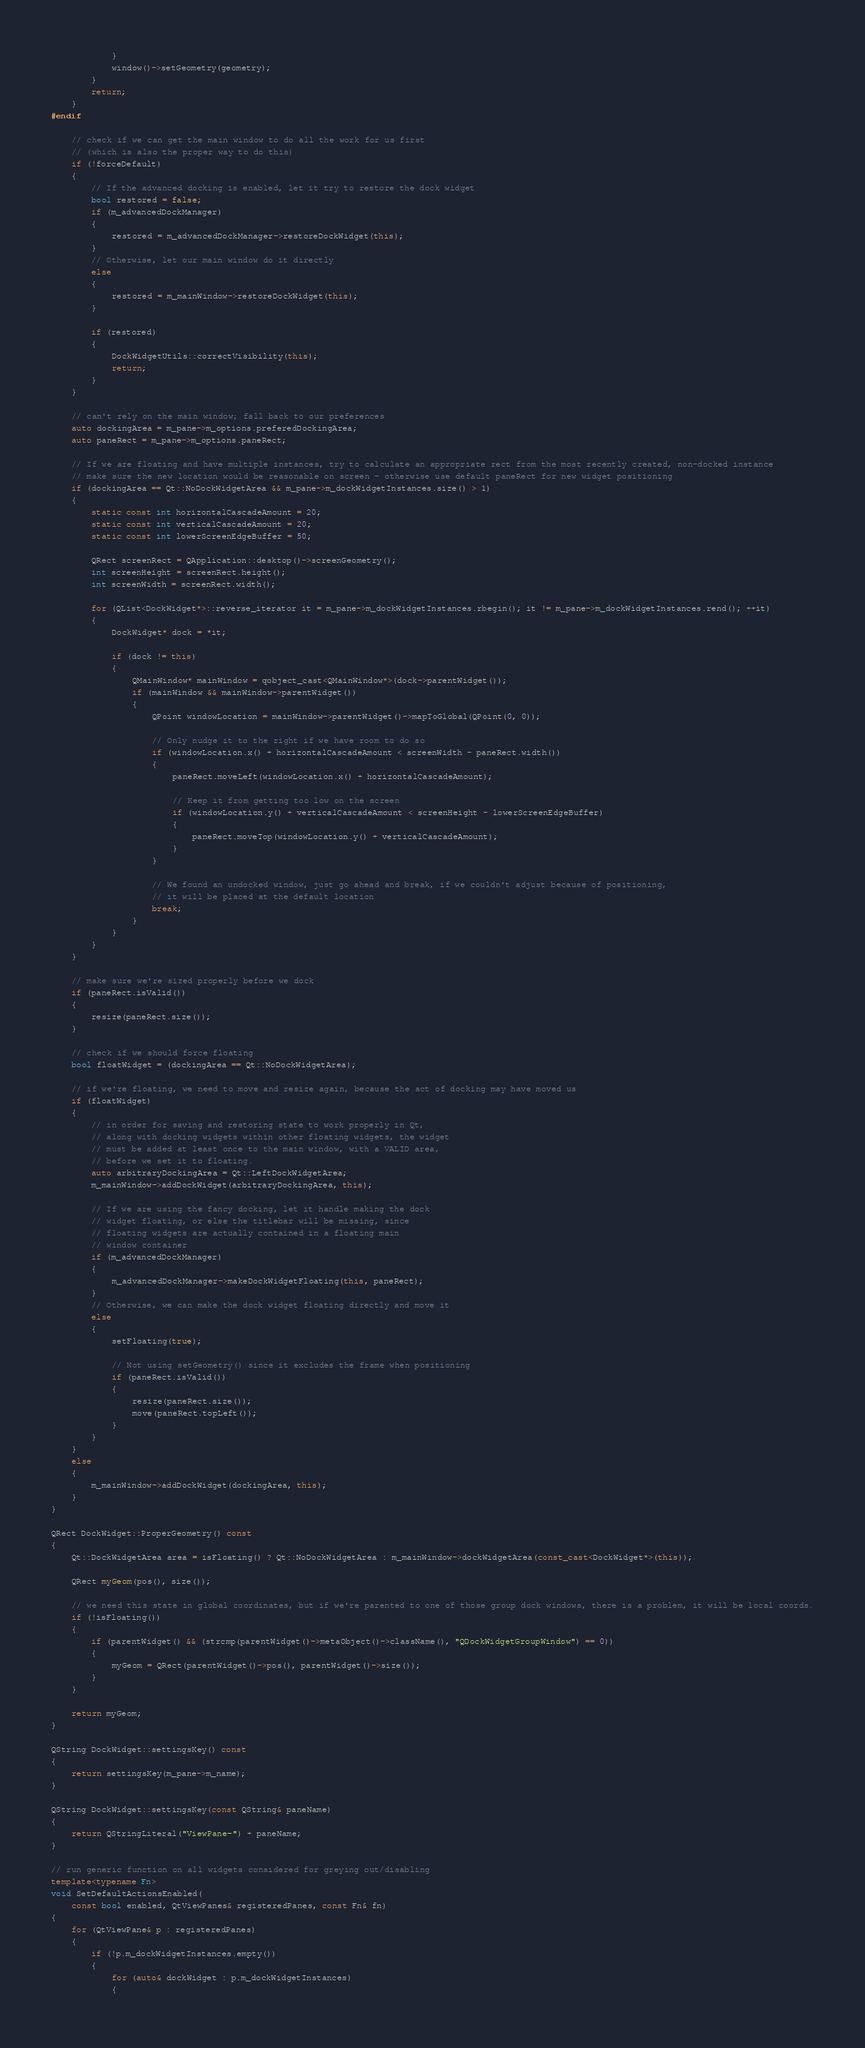Convert code to text. <code><loc_0><loc_0><loc_500><loc_500><_C++_>            }
            window()->setGeometry(geometry);
        }
        return;
    }
#endif

    // check if we can get the main window to do all the work for us first
    // (which is also the proper way to do this)
    if (!forceDefault)
    {
        // If the advanced docking is enabled, let it try to restore the dock widget
        bool restored = false;
        if (m_advancedDockManager)
        {
            restored = m_advancedDockManager->restoreDockWidget(this);
        }
        // Otherwise, let our main window do it directly
        else
        {
            restored = m_mainWindow->restoreDockWidget(this);
        }

        if (restored)
        {
            DockWidgetUtils::correctVisibility(this);
            return;
        }
    }

    // can't rely on the main window; fall back to our preferences
    auto dockingArea = m_pane->m_options.preferedDockingArea;
    auto paneRect = m_pane->m_options.paneRect;

    // If we are floating and have multiple instances, try to calculate an appropriate rect from the most recently created, non-docked instance
    // make sure the new location would be reasonable on screen - otherwise use default paneRect for new widget positioning
    if (dockingArea == Qt::NoDockWidgetArea && m_pane->m_dockWidgetInstances.size() > 1)
    {
        static const int horizontalCascadeAmount = 20;
        static const int verticalCascadeAmount = 20;
        static const int lowerScreenEdgeBuffer = 50;

        QRect screenRect = QApplication::desktop()->screenGeometry();
        int screenHeight = screenRect.height();
        int screenWidth = screenRect.width();

        for (QList<DockWidget*>::reverse_iterator it = m_pane->m_dockWidgetInstances.rbegin(); it != m_pane->m_dockWidgetInstances.rend(); ++it)
        {
            DockWidget* dock = *it;

            if (dock != this)
            {
                QMainWindow* mainWindow = qobject_cast<QMainWindow*>(dock->parentWidget());
                if (mainWindow && mainWindow->parentWidget())
                {
                    QPoint windowLocation = mainWindow->parentWidget()->mapToGlobal(QPoint(0, 0));

                    // Only nudge it to the right if we have room to do so
                    if (windowLocation.x() + horizontalCascadeAmount < screenWidth - paneRect.width())
                    {
                        paneRect.moveLeft(windowLocation.x() + horizontalCascadeAmount);

                        // Keep it from getting too low on the screen
                        if (windowLocation.y() + verticalCascadeAmount < screenHeight - lowerScreenEdgeBuffer)
                        {
                            paneRect.moveTop(windowLocation.y() + verticalCascadeAmount);
                        }
                    }

                    // We found an undocked window, just go ahead and break, if we couldn't adjust because of positioning,
                    // it will be placed at the default location
                    break;
                }
            }
        }
    }

    // make sure we're sized properly before we dock
    if (paneRect.isValid())
    {
        resize(paneRect.size());
    }

    // check if we should force floating
    bool floatWidget = (dockingArea == Qt::NoDockWidgetArea);

    // if we're floating, we need to move and resize again, because the act of docking may have moved us
    if (floatWidget)
    {
        // in order for saving and restoring state to work properly in Qt,
        // along with docking widgets within other floating widgets, the widget
        // must be added at least once to the main window, with a VALID area,
        // before we set it to floating.
        auto arbitraryDockingArea = Qt::LeftDockWidgetArea;
        m_mainWindow->addDockWidget(arbitraryDockingArea, this);

        // If we are using the fancy docking, let it handle making the dock
        // widget floating, or else the titlebar will be missing, since
        // floating widgets are actually contained in a floating main
        // window container
        if (m_advancedDockManager)
        {
            m_advancedDockManager->makeDockWidgetFloating(this, paneRect);
        }
        // Otherwise, we can make the dock widget floating directly and move it
        else
        {
            setFloating(true);

            // Not using setGeometry() since it excludes the frame when positioning
            if (paneRect.isValid())
            {
                resize(paneRect.size());
                move(paneRect.topLeft());
            }
        }
    }
    else
    {
        m_mainWindow->addDockWidget(dockingArea, this);
    }
}

QRect DockWidget::ProperGeometry() const
{
    Qt::DockWidgetArea area = isFloating() ? Qt::NoDockWidgetArea : m_mainWindow->dockWidgetArea(const_cast<DockWidget*>(this));

    QRect myGeom(pos(), size());

    // we need this state in global coordinates, but if we're parented to one of those group dock windows, there is a problem, it will be local coords.
    if (!isFloating())
    {
        if (parentWidget() && (strcmp(parentWidget()->metaObject()->className(), "QDockWidgetGroupWindow") == 0))
        {
            myGeom = QRect(parentWidget()->pos(), parentWidget()->size());
        }
    }

    return myGeom;
}

QString DockWidget::settingsKey() const
{
    return settingsKey(m_pane->m_name);
}

QString DockWidget::settingsKey(const QString& paneName)
{
    return QStringLiteral("ViewPane-") + paneName;
}

// run generic function on all widgets considered for greying out/disabling
template<typename Fn>
void SetDefaultActionsEnabled(
    const bool enabled, QtViewPanes& registeredPanes, const Fn& fn)
{
    for (QtViewPane& p : registeredPanes)
    {
        if (!p.m_dockWidgetInstances.empty())
        {
            for (auto& dockWidget : p.m_dockWidgetInstances)
            {</code> 